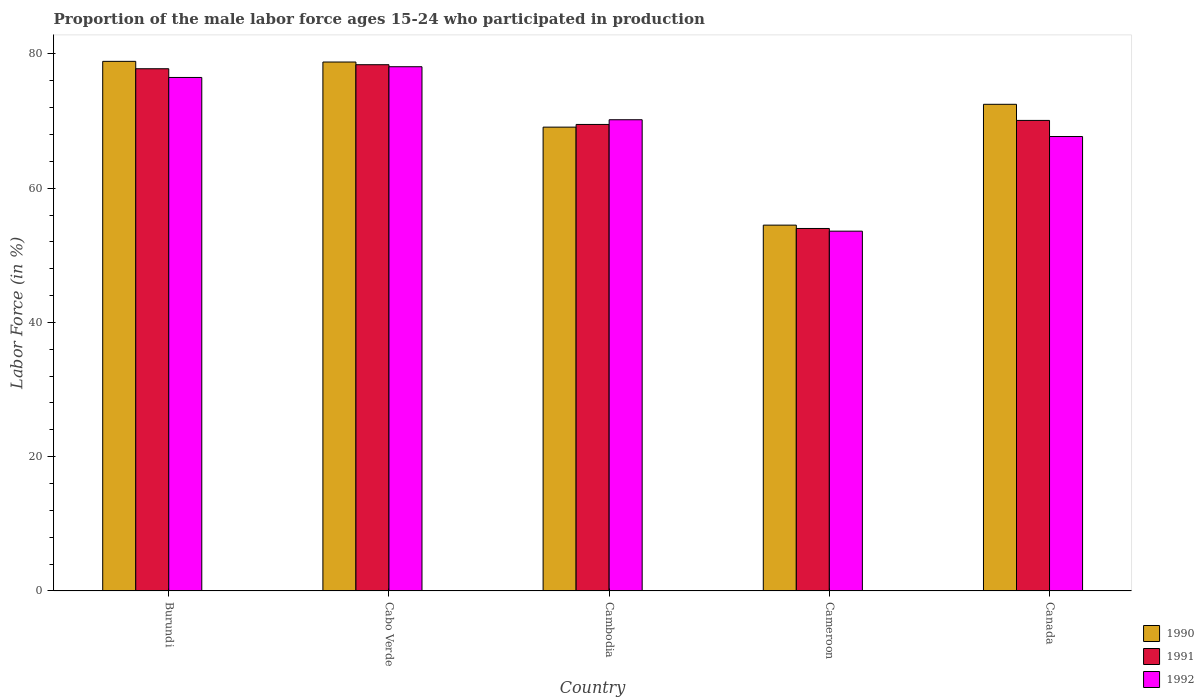How many different coloured bars are there?
Offer a very short reply. 3. Are the number of bars per tick equal to the number of legend labels?
Ensure brevity in your answer.  Yes. Are the number of bars on each tick of the X-axis equal?
Give a very brief answer. Yes. How many bars are there on the 2nd tick from the left?
Your answer should be very brief. 3. How many bars are there on the 5th tick from the right?
Ensure brevity in your answer.  3. What is the label of the 1st group of bars from the left?
Your response must be concise. Burundi. What is the proportion of the male labor force who participated in production in 1991 in Cameroon?
Your response must be concise. 54. Across all countries, what is the maximum proportion of the male labor force who participated in production in 1991?
Provide a short and direct response. 78.4. Across all countries, what is the minimum proportion of the male labor force who participated in production in 1992?
Your answer should be compact. 53.6. In which country was the proportion of the male labor force who participated in production in 1991 maximum?
Offer a very short reply. Cabo Verde. In which country was the proportion of the male labor force who participated in production in 1991 minimum?
Offer a very short reply. Cameroon. What is the total proportion of the male labor force who participated in production in 1992 in the graph?
Ensure brevity in your answer.  346.1. What is the difference between the proportion of the male labor force who participated in production in 1992 in Cabo Verde and that in Canada?
Your answer should be compact. 10.4. What is the difference between the proportion of the male labor force who participated in production in 1991 in Cambodia and the proportion of the male labor force who participated in production in 1992 in Cabo Verde?
Offer a very short reply. -8.6. What is the average proportion of the male labor force who participated in production in 1991 per country?
Offer a very short reply. 69.96. What is the difference between the proportion of the male labor force who participated in production of/in 1991 and proportion of the male labor force who participated in production of/in 1990 in Burundi?
Keep it short and to the point. -1.1. In how many countries, is the proportion of the male labor force who participated in production in 1992 greater than 64 %?
Offer a very short reply. 4. What is the ratio of the proportion of the male labor force who participated in production in 1992 in Burundi to that in Cabo Verde?
Offer a terse response. 0.98. Is the proportion of the male labor force who participated in production in 1991 in Cambodia less than that in Cameroon?
Provide a succinct answer. No. Is the difference between the proportion of the male labor force who participated in production in 1991 in Cabo Verde and Cameroon greater than the difference between the proportion of the male labor force who participated in production in 1990 in Cabo Verde and Cameroon?
Keep it short and to the point. Yes. What is the difference between the highest and the second highest proportion of the male labor force who participated in production in 1990?
Give a very brief answer. -6.3. What is the difference between the highest and the lowest proportion of the male labor force who participated in production in 1990?
Make the answer very short. 24.4. Is the sum of the proportion of the male labor force who participated in production in 1990 in Cabo Verde and Cameroon greater than the maximum proportion of the male labor force who participated in production in 1991 across all countries?
Ensure brevity in your answer.  Yes. Does the graph contain any zero values?
Keep it short and to the point. No. Does the graph contain grids?
Provide a short and direct response. No. How are the legend labels stacked?
Provide a short and direct response. Vertical. What is the title of the graph?
Offer a very short reply. Proportion of the male labor force ages 15-24 who participated in production. Does "1980" appear as one of the legend labels in the graph?
Provide a succinct answer. No. What is the label or title of the X-axis?
Keep it short and to the point. Country. What is the Labor Force (in %) of 1990 in Burundi?
Your response must be concise. 78.9. What is the Labor Force (in %) of 1991 in Burundi?
Ensure brevity in your answer.  77.8. What is the Labor Force (in %) in 1992 in Burundi?
Your answer should be very brief. 76.5. What is the Labor Force (in %) of 1990 in Cabo Verde?
Provide a succinct answer. 78.8. What is the Labor Force (in %) in 1991 in Cabo Verde?
Your response must be concise. 78.4. What is the Labor Force (in %) of 1992 in Cabo Verde?
Provide a succinct answer. 78.1. What is the Labor Force (in %) in 1990 in Cambodia?
Give a very brief answer. 69.1. What is the Labor Force (in %) in 1991 in Cambodia?
Ensure brevity in your answer.  69.5. What is the Labor Force (in %) in 1992 in Cambodia?
Keep it short and to the point. 70.2. What is the Labor Force (in %) of 1990 in Cameroon?
Offer a terse response. 54.5. What is the Labor Force (in %) in 1991 in Cameroon?
Ensure brevity in your answer.  54. What is the Labor Force (in %) in 1992 in Cameroon?
Offer a terse response. 53.6. What is the Labor Force (in %) in 1990 in Canada?
Your answer should be very brief. 72.5. What is the Labor Force (in %) in 1991 in Canada?
Provide a succinct answer. 70.1. What is the Labor Force (in %) in 1992 in Canada?
Provide a short and direct response. 67.7. Across all countries, what is the maximum Labor Force (in %) in 1990?
Give a very brief answer. 78.9. Across all countries, what is the maximum Labor Force (in %) of 1991?
Provide a short and direct response. 78.4. Across all countries, what is the maximum Labor Force (in %) in 1992?
Keep it short and to the point. 78.1. Across all countries, what is the minimum Labor Force (in %) in 1990?
Your response must be concise. 54.5. Across all countries, what is the minimum Labor Force (in %) of 1992?
Provide a short and direct response. 53.6. What is the total Labor Force (in %) in 1990 in the graph?
Provide a short and direct response. 353.8. What is the total Labor Force (in %) in 1991 in the graph?
Your answer should be compact. 349.8. What is the total Labor Force (in %) of 1992 in the graph?
Give a very brief answer. 346.1. What is the difference between the Labor Force (in %) in 1990 in Burundi and that in Cabo Verde?
Provide a succinct answer. 0.1. What is the difference between the Labor Force (in %) in 1991 in Burundi and that in Cabo Verde?
Provide a short and direct response. -0.6. What is the difference between the Labor Force (in %) of 1992 in Burundi and that in Cambodia?
Keep it short and to the point. 6.3. What is the difference between the Labor Force (in %) in 1990 in Burundi and that in Cameroon?
Your answer should be compact. 24.4. What is the difference between the Labor Force (in %) in 1991 in Burundi and that in Cameroon?
Make the answer very short. 23.8. What is the difference between the Labor Force (in %) of 1992 in Burundi and that in Cameroon?
Provide a succinct answer. 22.9. What is the difference between the Labor Force (in %) of 1990 in Cabo Verde and that in Cambodia?
Your response must be concise. 9.7. What is the difference between the Labor Force (in %) of 1991 in Cabo Verde and that in Cambodia?
Give a very brief answer. 8.9. What is the difference between the Labor Force (in %) of 1990 in Cabo Verde and that in Cameroon?
Keep it short and to the point. 24.3. What is the difference between the Labor Force (in %) of 1991 in Cabo Verde and that in Cameroon?
Make the answer very short. 24.4. What is the difference between the Labor Force (in %) of 1992 in Cabo Verde and that in Cameroon?
Your answer should be compact. 24.5. What is the difference between the Labor Force (in %) in 1990 in Cabo Verde and that in Canada?
Your answer should be compact. 6.3. What is the difference between the Labor Force (in %) of 1991 in Cabo Verde and that in Canada?
Keep it short and to the point. 8.3. What is the difference between the Labor Force (in %) of 1990 in Cambodia and that in Cameroon?
Offer a terse response. 14.6. What is the difference between the Labor Force (in %) in 1992 in Cambodia and that in Cameroon?
Give a very brief answer. 16.6. What is the difference between the Labor Force (in %) of 1991 in Cameroon and that in Canada?
Keep it short and to the point. -16.1. What is the difference between the Labor Force (in %) in 1992 in Cameroon and that in Canada?
Provide a succinct answer. -14.1. What is the difference between the Labor Force (in %) of 1990 in Burundi and the Labor Force (in %) of 1991 in Cabo Verde?
Provide a short and direct response. 0.5. What is the difference between the Labor Force (in %) in 1990 in Burundi and the Labor Force (in %) in 1992 in Cabo Verde?
Your answer should be compact. 0.8. What is the difference between the Labor Force (in %) in 1991 in Burundi and the Labor Force (in %) in 1992 in Cabo Verde?
Your answer should be compact. -0.3. What is the difference between the Labor Force (in %) of 1990 in Burundi and the Labor Force (in %) of 1992 in Cambodia?
Provide a succinct answer. 8.7. What is the difference between the Labor Force (in %) of 1991 in Burundi and the Labor Force (in %) of 1992 in Cambodia?
Make the answer very short. 7.6. What is the difference between the Labor Force (in %) of 1990 in Burundi and the Labor Force (in %) of 1991 in Cameroon?
Make the answer very short. 24.9. What is the difference between the Labor Force (in %) of 1990 in Burundi and the Labor Force (in %) of 1992 in Cameroon?
Your response must be concise. 25.3. What is the difference between the Labor Force (in %) of 1991 in Burundi and the Labor Force (in %) of 1992 in Cameroon?
Offer a terse response. 24.2. What is the difference between the Labor Force (in %) of 1990 in Burundi and the Labor Force (in %) of 1991 in Canada?
Your answer should be compact. 8.8. What is the difference between the Labor Force (in %) in 1991 in Burundi and the Labor Force (in %) in 1992 in Canada?
Your answer should be very brief. 10.1. What is the difference between the Labor Force (in %) of 1990 in Cabo Verde and the Labor Force (in %) of 1991 in Cambodia?
Your answer should be compact. 9.3. What is the difference between the Labor Force (in %) in 1991 in Cabo Verde and the Labor Force (in %) in 1992 in Cambodia?
Your answer should be very brief. 8.2. What is the difference between the Labor Force (in %) of 1990 in Cabo Verde and the Labor Force (in %) of 1991 in Cameroon?
Your answer should be compact. 24.8. What is the difference between the Labor Force (in %) in 1990 in Cabo Verde and the Labor Force (in %) in 1992 in Cameroon?
Give a very brief answer. 25.2. What is the difference between the Labor Force (in %) in 1991 in Cabo Verde and the Labor Force (in %) in 1992 in Cameroon?
Your answer should be compact. 24.8. What is the difference between the Labor Force (in %) in 1990 in Cambodia and the Labor Force (in %) in 1991 in Cameroon?
Ensure brevity in your answer.  15.1. What is the difference between the Labor Force (in %) of 1990 in Cambodia and the Labor Force (in %) of 1992 in Cameroon?
Make the answer very short. 15.5. What is the difference between the Labor Force (in %) of 1990 in Cambodia and the Labor Force (in %) of 1992 in Canada?
Make the answer very short. 1.4. What is the difference between the Labor Force (in %) in 1991 in Cambodia and the Labor Force (in %) in 1992 in Canada?
Provide a short and direct response. 1.8. What is the difference between the Labor Force (in %) in 1990 in Cameroon and the Labor Force (in %) in 1991 in Canada?
Offer a terse response. -15.6. What is the difference between the Labor Force (in %) of 1991 in Cameroon and the Labor Force (in %) of 1992 in Canada?
Your answer should be very brief. -13.7. What is the average Labor Force (in %) of 1990 per country?
Provide a short and direct response. 70.76. What is the average Labor Force (in %) of 1991 per country?
Make the answer very short. 69.96. What is the average Labor Force (in %) of 1992 per country?
Your answer should be very brief. 69.22. What is the difference between the Labor Force (in %) of 1990 and Labor Force (in %) of 1991 in Burundi?
Offer a terse response. 1.1. What is the difference between the Labor Force (in %) in 1990 and Labor Force (in %) in 1991 in Cabo Verde?
Keep it short and to the point. 0.4. What is the difference between the Labor Force (in %) of 1990 and Labor Force (in %) of 1992 in Cabo Verde?
Ensure brevity in your answer.  0.7. What is the difference between the Labor Force (in %) in 1990 and Labor Force (in %) in 1991 in Cambodia?
Offer a very short reply. -0.4. What is the difference between the Labor Force (in %) of 1990 and Labor Force (in %) of 1992 in Cambodia?
Your response must be concise. -1.1. What is the difference between the Labor Force (in %) of 1990 and Labor Force (in %) of 1992 in Cameroon?
Offer a terse response. 0.9. What is the difference between the Labor Force (in %) of 1990 and Labor Force (in %) of 1991 in Canada?
Provide a short and direct response. 2.4. What is the difference between the Labor Force (in %) of 1990 and Labor Force (in %) of 1992 in Canada?
Keep it short and to the point. 4.8. What is the difference between the Labor Force (in %) in 1991 and Labor Force (in %) in 1992 in Canada?
Your response must be concise. 2.4. What is the ratio of the Labor Force (in %) in 1991 in Burundi to that in Cabo Verde?
Make the answer very short. 0.99. What is the ratio of the Labor Force (in %) in 1992 in Burundi to that in Cabo Verde?
Your answer should be compact. 0.98. What is the ratio of the Labor Force (in %) of 1990 in Burundi to that in Cambodia?
Give a very brief answer. 1.14. What is the ratio of the Labor Force (in %) of 1991 in Burundi to that in Cambodia?
Give a very brief answer. 1.12. What is the ratio of the Labor Force (in %) in 1992 in Burundi to that in Cambodia?
Your response must be concise. 1.09. What is the ratio of the Labor Force (in %) in 1990 in Burundi to that in Cameroon?
Keep it short and to the point. 1.45. What is the ratio of the Labor Force (in %) in 1991 in Burundi to that in Cameroon?
Offer a terse response. 1.44. What is the ratio of the Labor Force (in %) of 1992 in Burundi to that in Cameroon?
Ensure brevity in your answer.  1.43. What is the ratio of the Labor Force (in %) in 1990 in Burundi to that in Canada?
Provide a succinct answer. 1.09. What is the ratio of the Labor Force (in %) of 1991 in Burundi to that in Canada?
Your response must be concise. 1.11. What is the ratio of the Labor Force (in %) of 1992 in Burundi to that in Canada?
Ensure brevity in your answer.  1.13. What is the ratio of the Labor Force (in %) of 1990 in Cabo Verde to that in Cambodia?
Your response must be concise. 1.14. What is the ratio of the Labor Force (in %) in 1991 in Cabo Verde to that in Cambodia?
Give a very brief answer. 1.13. What is the ratio of the Labor Force (in %) in 1992 in Cabo Verde to that in Cambodia?
Your response must be concise. 1.11. What is the ratio of the Labor Force (in %) in 1990 in Cabo Verde to that in Cameroon?
Your answer should be compact. 1.45. What is the ratio of the Labor Force (in %) in 1991 in Cabo Verde to that in Cameroon?
Keep it short and to the point. 1.45. What is the ratio of the Labor Force (in %) in 1992 in Cabo Verde to that in Cameroon?
Your response must be concise. 1.46. What is the ratio of the Labor Force (in %) of 1990 in Cabo Verde to that in Canada?
Make the answer very short. 1.09. What is the ratio of the Labor Force (in %) of 1991 in Cabo Verde to that in Canada?
Offer a terse response. 1.12. What is the ratio of the Labor Force (in %) in 1992 in Cabo Verde to that in Canada?
Offer a very short reply. 1.15. What is the ratio of the Labor Force (in %) in 1990 in Cambodia to that in Cameroon?
Provide a short and direct response. 1.27. What is the ratio of the Labor Force (in %) of 1991 in Cambodia to that in Cameroon?
Keep it short and to the point. 1.29. What is the ratio of the Labor Force (in %) in 1992 in Cambodia to that in Cameroon?
Give a very brief answer. 1.31. What is the ratio of the Labor Force (in %) of 1990 in Cambodia to that in Canada?
Provide a succinct answer. 0.95. What is the ratio of the Labor Force (in %) in 1991 in Cambodia to that in Canada?
Your response must be concise. 0.99. What is the ratio of the Labor Force (in %) in 1992 in Cambodia to that in Canada?
Give a very brief answer. 1.04. What is the ratio of the Labor Force (in %) in 1990 in Cameroon to that in Canada?
Make the answer very short. 0.75. What is the ratio of the Labor Force (in %) of 1991 in Cameroon to that in Canada?
Offer a terse response. 0.77. What is the ratio of the Labor Force (in %) of 1992 in Cameroon to that in Canada?
Provide a succinct answer. 0.79. What is the difference between the highest and the second highest Labor Force (in %) of 1990?
Your response must be concise. 0.1. What is the difference between the highest and the second highest Labor Force (in %) of 1991?
Ensure brevity in your answer.  0.6. What is the difference between the highest and the second highest Labor Force (in %) of 1992?
Provide a short and direct response. 1.6. What is the difference between the highest and the lowest Labor Force (in %) of 1990?
Your answer should be very brief. 24.4. What is the difference between the highest and the lowest Labor Force (in %) of 1991?
Offer a very short reply. 24.4. 